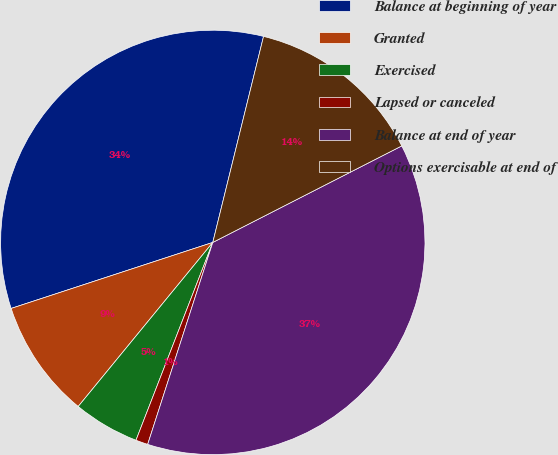Convert chart to OTSL. <chart><loc_0><loc_0><loc_500><loc_500><pie_chart><fcel>Balance at beginning of year<fcel>Granted<fcel>Exercised<fcel>Lapsed or canceled<fcel>Balance at end of year<fcel>Options exercisable at end of<nl><fcel>33.88%<fcel>9.03%<fcel>5.04%<fcel>0.93%<fcel>37.48%<fcel>13.64%<nl></chart> 